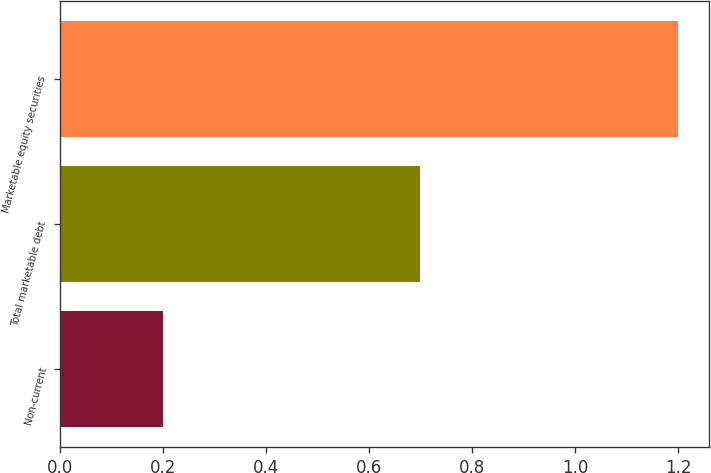<chart> <loc_0><loc_0><loc_500><loc_500><bar_chart><fcel>Non-current<fcel>Total marketable debt<fcel>Marketable equity securities<nl><fcel>0.2<fcel>0.7<fcel>1.2<nl></chart> 